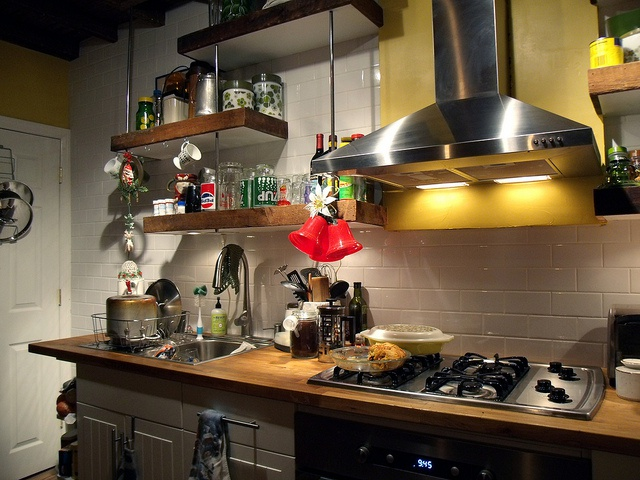Describe the objects in this image and their specific colors. I can see oven in black, navy, gray, and white tones, oven in black, gray, and darkgray tones, sink in black and gray tones, bowl in black, tan, olive, and gray tones, and bowl in black, olive, gray, and maroon tones in this image. 